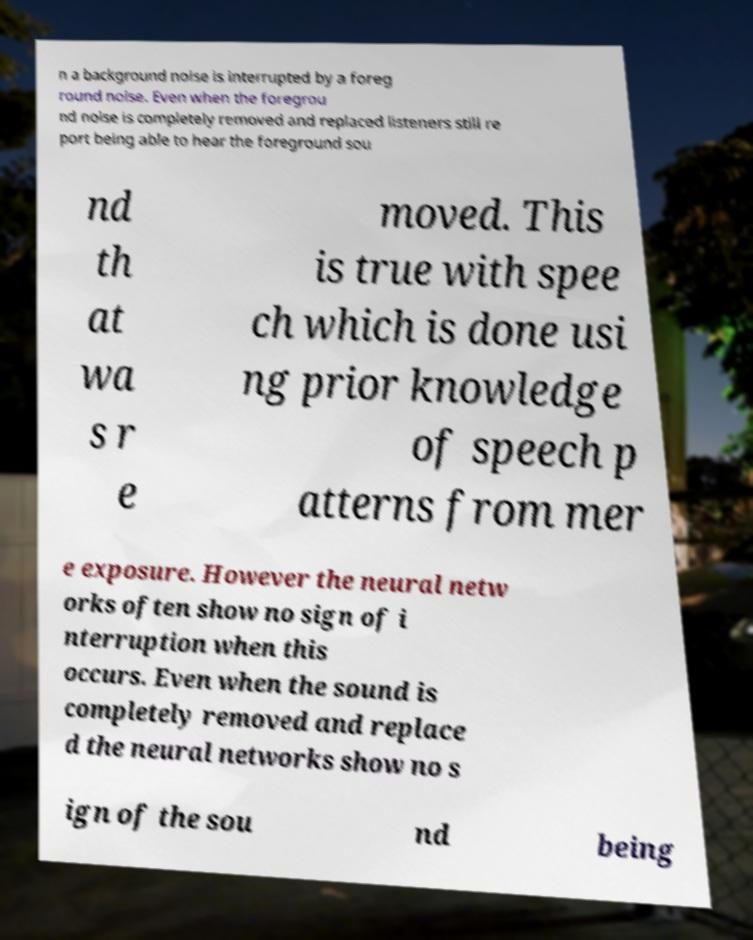Can you accurately transcribe the text from the provided image for me? n a background noise is interrupted by a foreg round noise. Even when the foregrou nd noise is completely removed and replaced listeners still re port being able to hear the foreground sou nd th at wa s r e moved. This is true with spee ch which is done usi ng prior knowledge of speech p atterns from mer e exposure. However the neural netw orks often show no sign of i nterruption when this occurs. Even when the sound is completely removed and replace d the neural networks show no s ign of the sou nd being 